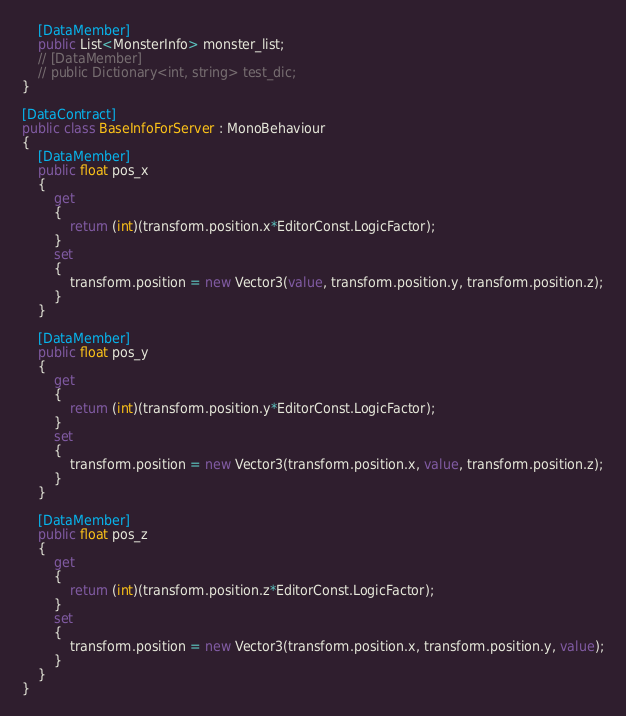<code> <loc_0><loc_0><loc_500><loc_500><_C#_>    [DataMember]
    public List<MonsterInfo> monster_list;
    // [DataMember]
    // public Dictionary<int, string> test_dic;
}

[DataContract]
public class BaseInfoForServer : MonoBehaviour
{
    [DataMember]
    public float pos_x
    {
        get
        {
            return (int)(transform.position.x*EditorConst.LogicFactor);
        }
        set
        {
            transform.position = new Vector3(value, transform.position.y, transform.position.z);
        }
    }

    [DataMember]
    public float pos_y
    {
        get
        {
            return (int)(transform.position.y*EditorConst.LogicFactor);
        }
        set
        {
            transform.position = new Vector3(transform.position.x, value, transform.position.z);
        }
    }

    [DataMember]
    public float pos_z
    {
        get
        {
            return (int)(transform.position.z*EditorConst.LogicFactor);
        }
        set
        {
            transform.position = new Vector3(transform.position.x, transform.position.y, value);
        }
    }
}</code> 